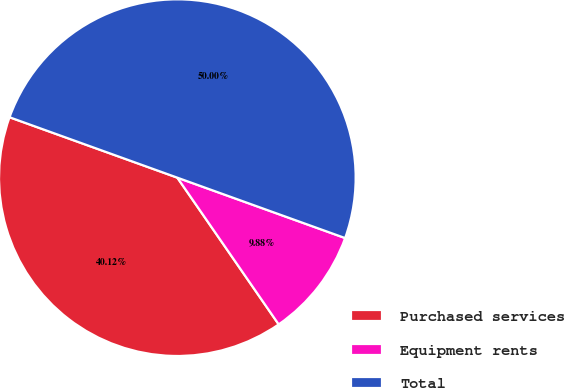Convert chart to OTSL. <chart><loc_0><loc_0><loc_500><loc_500><pie_chart><fcel>Purchased services<fcel>Equipment rents<fcel>Total<nl><fcel>40.12%<fcel>9.88%<fcel>50.0%<nl></chart> 